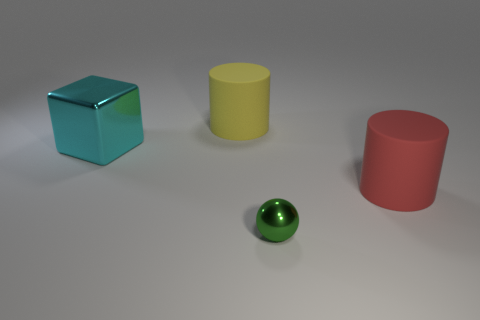Add 3 big yellow cylinders. How many objects exist? 7 Subtract 2 cylinders. How many cylinders are left? 0 Subtract all cubes. How many objects are left? 3 Subtract all tiny yellow matte things. Subtract all cyan things. How many objects are left? 3 Add 3 cyan shiny objects. How many cyan shiny objects are left? 4 Add 1 small spheres. How many small spheres exist? 2 Subtract all red cylinders. How many cylinders are left? 1 Subtract 0 green blocks. How many objects are left? 4 Subtract all yellow cylinders. Subtract all blue blocks. How many cylinders are left? 1 Subtract all red spheres. How many yellow cylinders are left? 1 